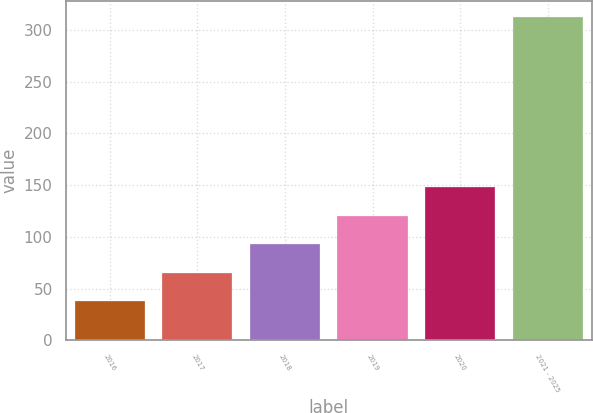<chart> <loc_0><loc_0><loc_500><loc_500><bar_chart><fcel>2016<fcel>2017<fcel>2018<fcel>2019<fcel>2020<fcel>2021 - 2025<nl><fcel>37.8<fcel>65.29<fcel>92.78<fcel>120.27<fcel>147.76<fcel>312.7<nl></chart> 